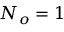Convert formula to latex. <formula><loc_0><loc_0><loc_500><loc_500>N _ { o } = 1</formula> 